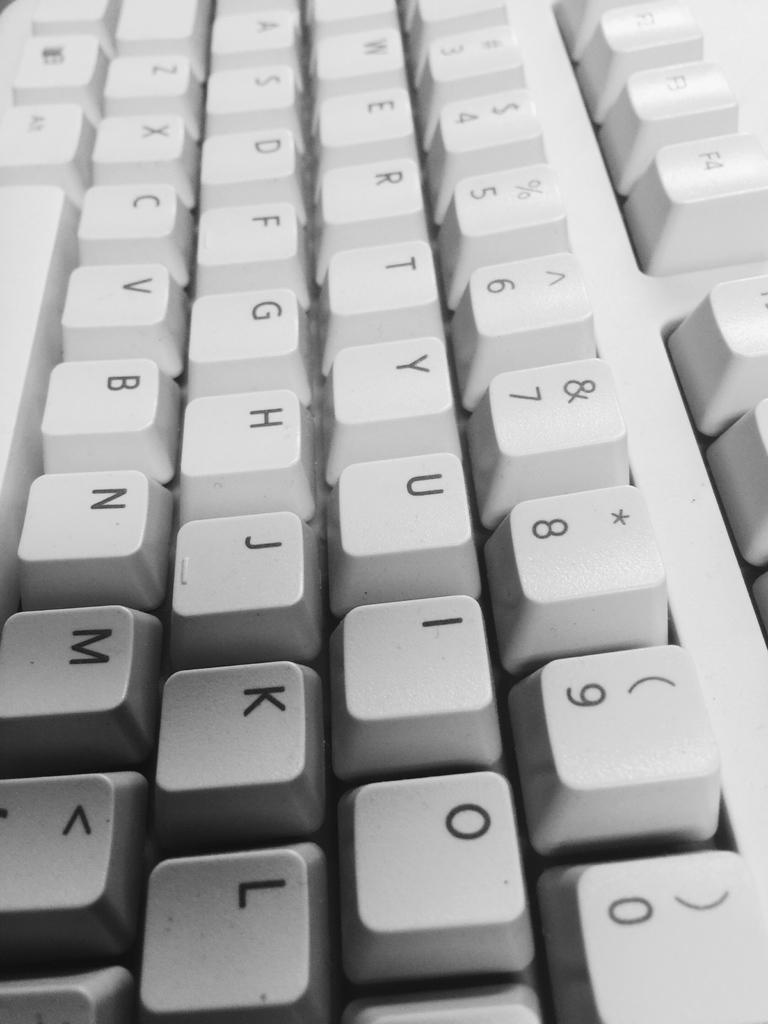What other character is found on the key that has a 9 on it?
Make the answer very short. (. What key is on the bottom right corner?
Your answer should be very brief. 0. 